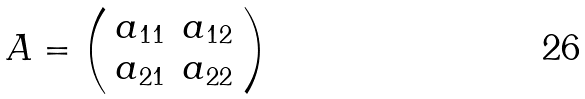<formula> <loc_0><loc_0><loc_500><loc_500>A = \left ( \begin{array} { l l } a _ { 1 1 } & a _ { 1 2 } \\ a _ { 2 1 } & a _ { 2 2 } \end{array} \right )</formula> 